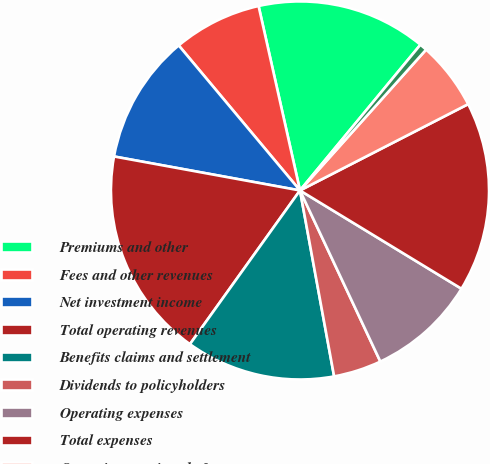Convert chart. <chart><loc_0><loc_0><loc_500><loc_500><pie_chart><fcel>Premiums and other<fcel>Fees and other revenues<fcel>Net investment income<fcel>Total operating revenues<fcel>Benefits claims and settlement<fcel>Dividends to policyholders<fcel>Operating expenses<fcel>Total expenses<fcel>Operating earnings before<fcel>Income taxes<nl><fcel>14.51%<fcel>7.57%<fcel>11.04%<fcel>17.99%<fcel>12.78%<fcel>4.1%<fcel>9.31%<fcel>16.25%<fcel>5.83%<fcel>0.63%<nl></chart> 